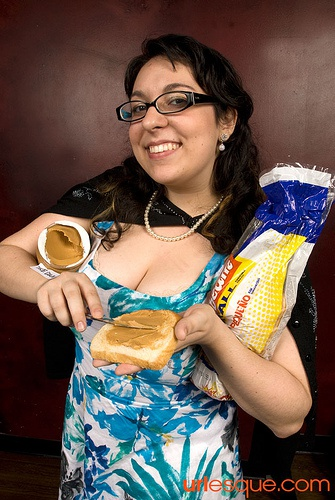Describe the objects in this image and their specific colors. I can see people in black, tan, and lightgray tones and knife in black, orange, olive, gray, and tan tones in this image. 